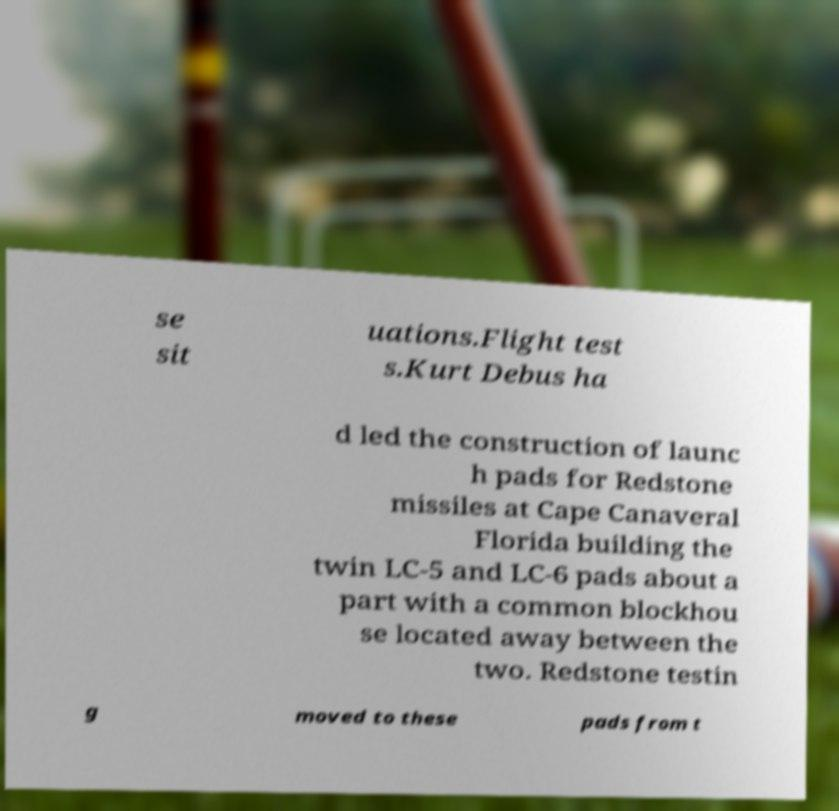What messages or text are displayed in this image? I need them in a readable, typed format. se sit uations.Flight test s.Kurt Debus ha d led the construction of launc h pads for Redstone missiles at Cape Canaveral Florida building the twin LC-5 and LC-6 pads about a part with a common blockhou se located away between the two. Redstone testin g moved to these pads from t 